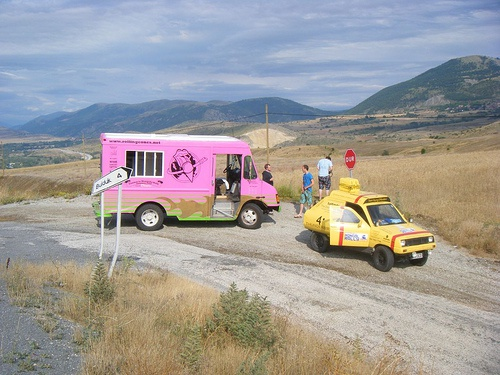Describe the objects in this image and their specific colors. I can see truck in darkgray, violet, white, gray, and black tones, truck in darkgray, khaki, gray, and ivory tones, car in darkgray, khaki, gray, and black tones, people in darkgray, tan, gray, and teal tones, and people in darkgray, lightgray, gray, and tan tones in this image. 